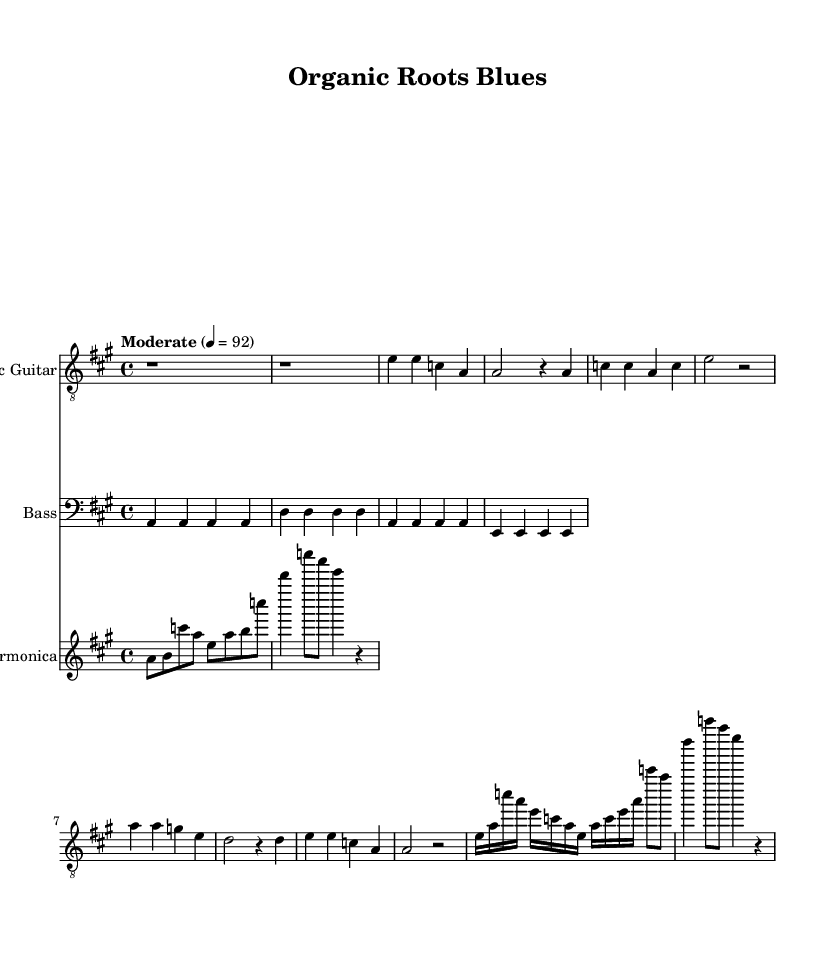What is the key signature of this music? The key signature shows one sharp, indicating that the piece is in A major. You can identify the key signature by looking at the clef section at the beginning of the staff.
Answer: A major What is the time signature of this music? The time signature is found at the beginning of the sheet music and is written as 4/4, meaning there are four beats in each measure and the quarter note receives one beat.
Answer: 4/4 What is the tempo marking of this music? The tempo is indicated right at the start of the score, stating "Moderate" with a beats per minute (BPM) indication of 92. This informs the performer to play at a moderate pace.
Answer: Moderate 4 = 92 How many measures are in the first verse? To determine the number of measures in the first verse, I can count the grouped section under the verse, which includes four measures based on the way the bars are broken down.
Answer: 4 What instruments are included in this piece? The instruments can be identified in the score by looking at the staff labels: Electric Guitar, Bass, and Harmonica are clearly stated at the beginning of their respective staves.
Answer: Electric Guitar, Bass, Harmonica What is the primary theme of the lyrics in this blues piece? The lyrics focus on sustainable and organic farming practices, as indicated by phrases like "Plowing fields under the hot sun" and "No chemicals, just nature's way." Analyzing the lyrics provides insight into the overall theme of the song.
Answer: Sustainable farming What type of musical form is commonly used in blues and is evident here? The music displays a typical structure of the blues genre, which often features a 12-bar format. In the score, despite simplified measures, the repetition and lyrical structure emphasize this traditional form.
Answer: 12-bar blues 